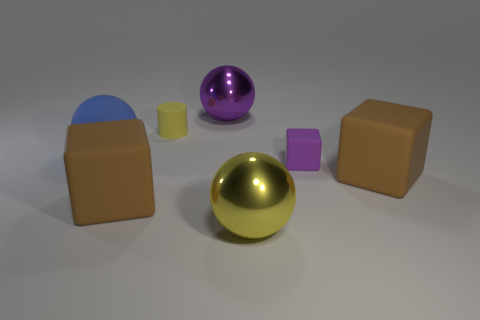How do the colors of the objects influence the mood of this scene? The varying colors of the objects contribute to a playful and diverse atmosphere. The bright and reflective surfaces catch the light in a manner that could evoke curiosity and a sense of modernity or design. 